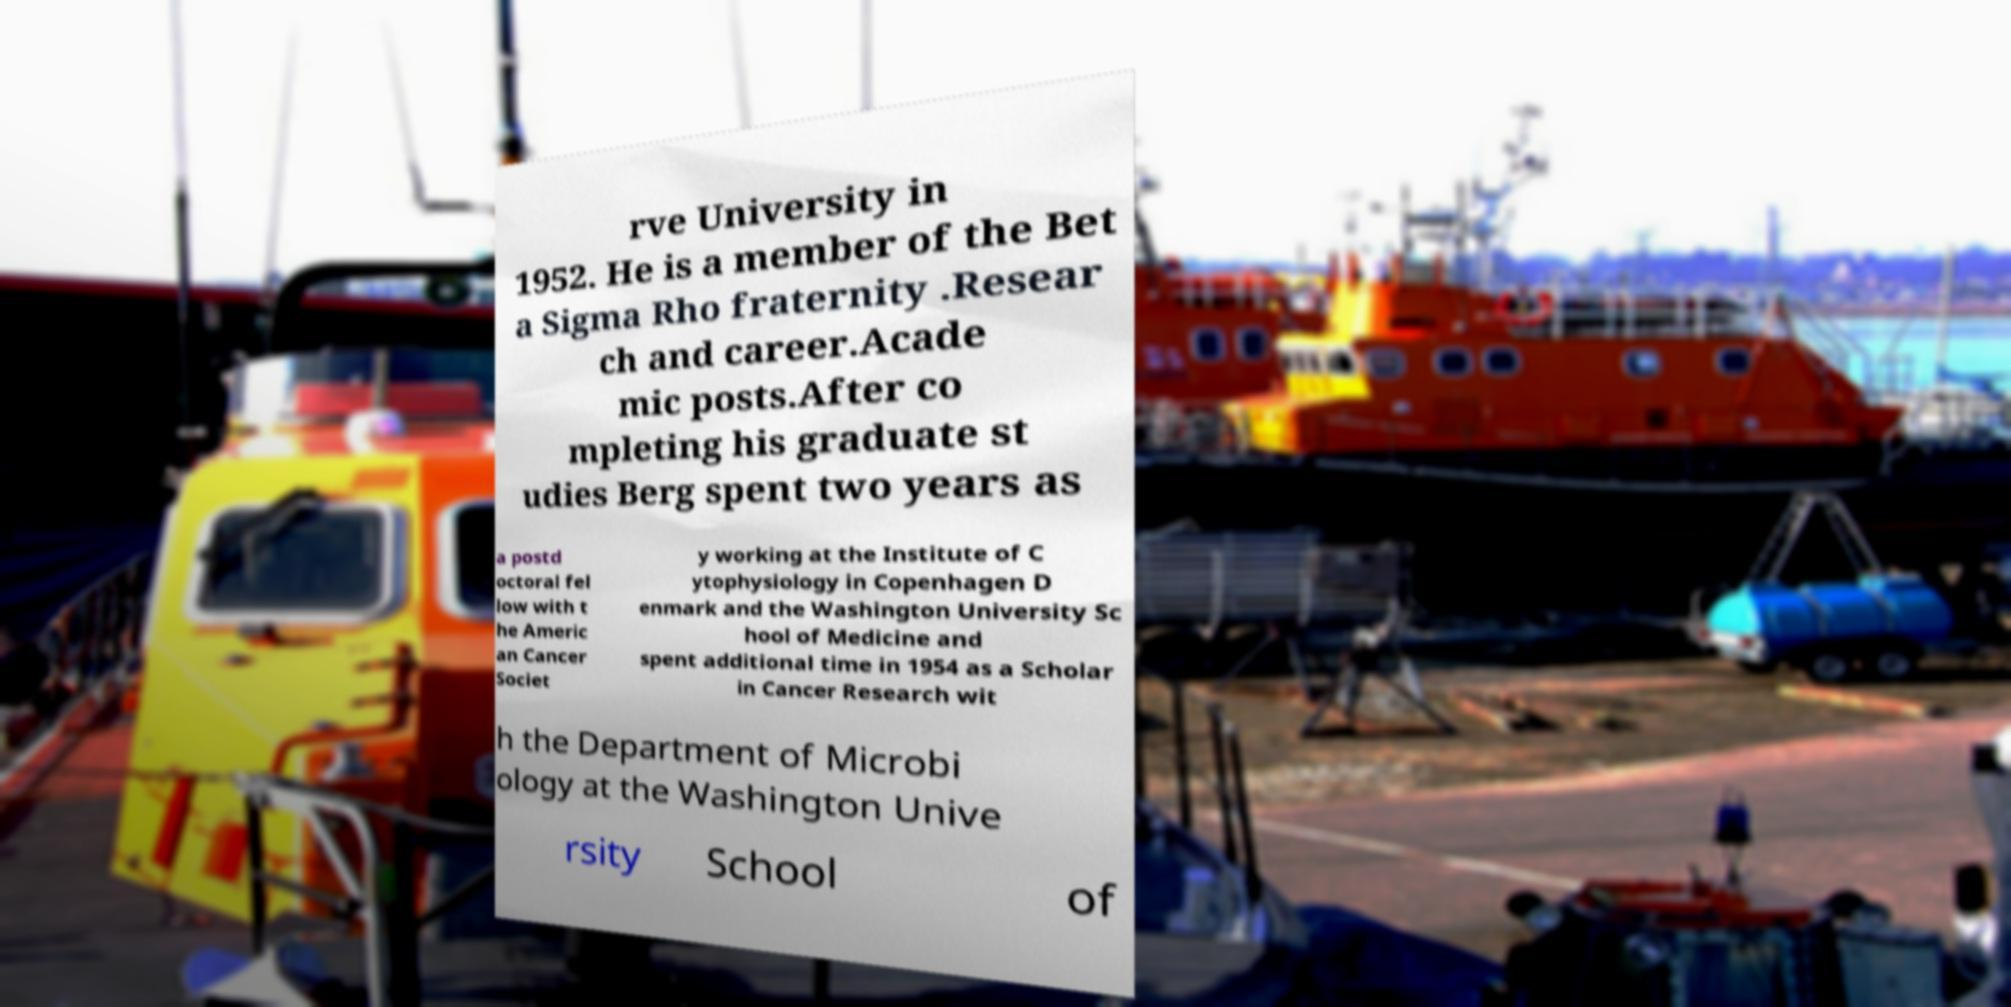Can you read and provide the text displayed in the image?This photo seems to have some interesting text. Can you extract and type it out for me? rve University in 1952. He is a member of the Bet a Sigma Rho fraternity .Resear ch and career.Acade mic posts.After co mpleting his graduate st udies Berg spent two years as a postd octoral fel low with t he Americ an Cancer Societ y working at the Institute of C ytophysiology in Copenhagen D enmark and the Washington University Sc hool of Medicine and spent additional time in 1954 as a Scholar in Cancer Research wit h the Department of Microbi ology at the Washington Unive rsity School of 